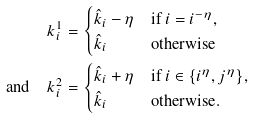<formula> <loc_0><loc_0><loc_500><loc_500>k ^ { 1 } _ { i } & = \begin{cases} \hat { k } _ { i } - \eta & \text {if } i = i ^ { - \eta } , \\ \hat { k } _ { i } & \text {otherwise} \end{cases} \\ \text {and} \quad k ^ { 2 } _ { i } & = \begin{cases} \hat { k } _ { i } + \eta & \text {if } i \in \{ i ^ { \eta } , j ^ { \eta } \} , \\ \hat { k } _ { i } & \text {otherwise} . \end{cases}</formula> 